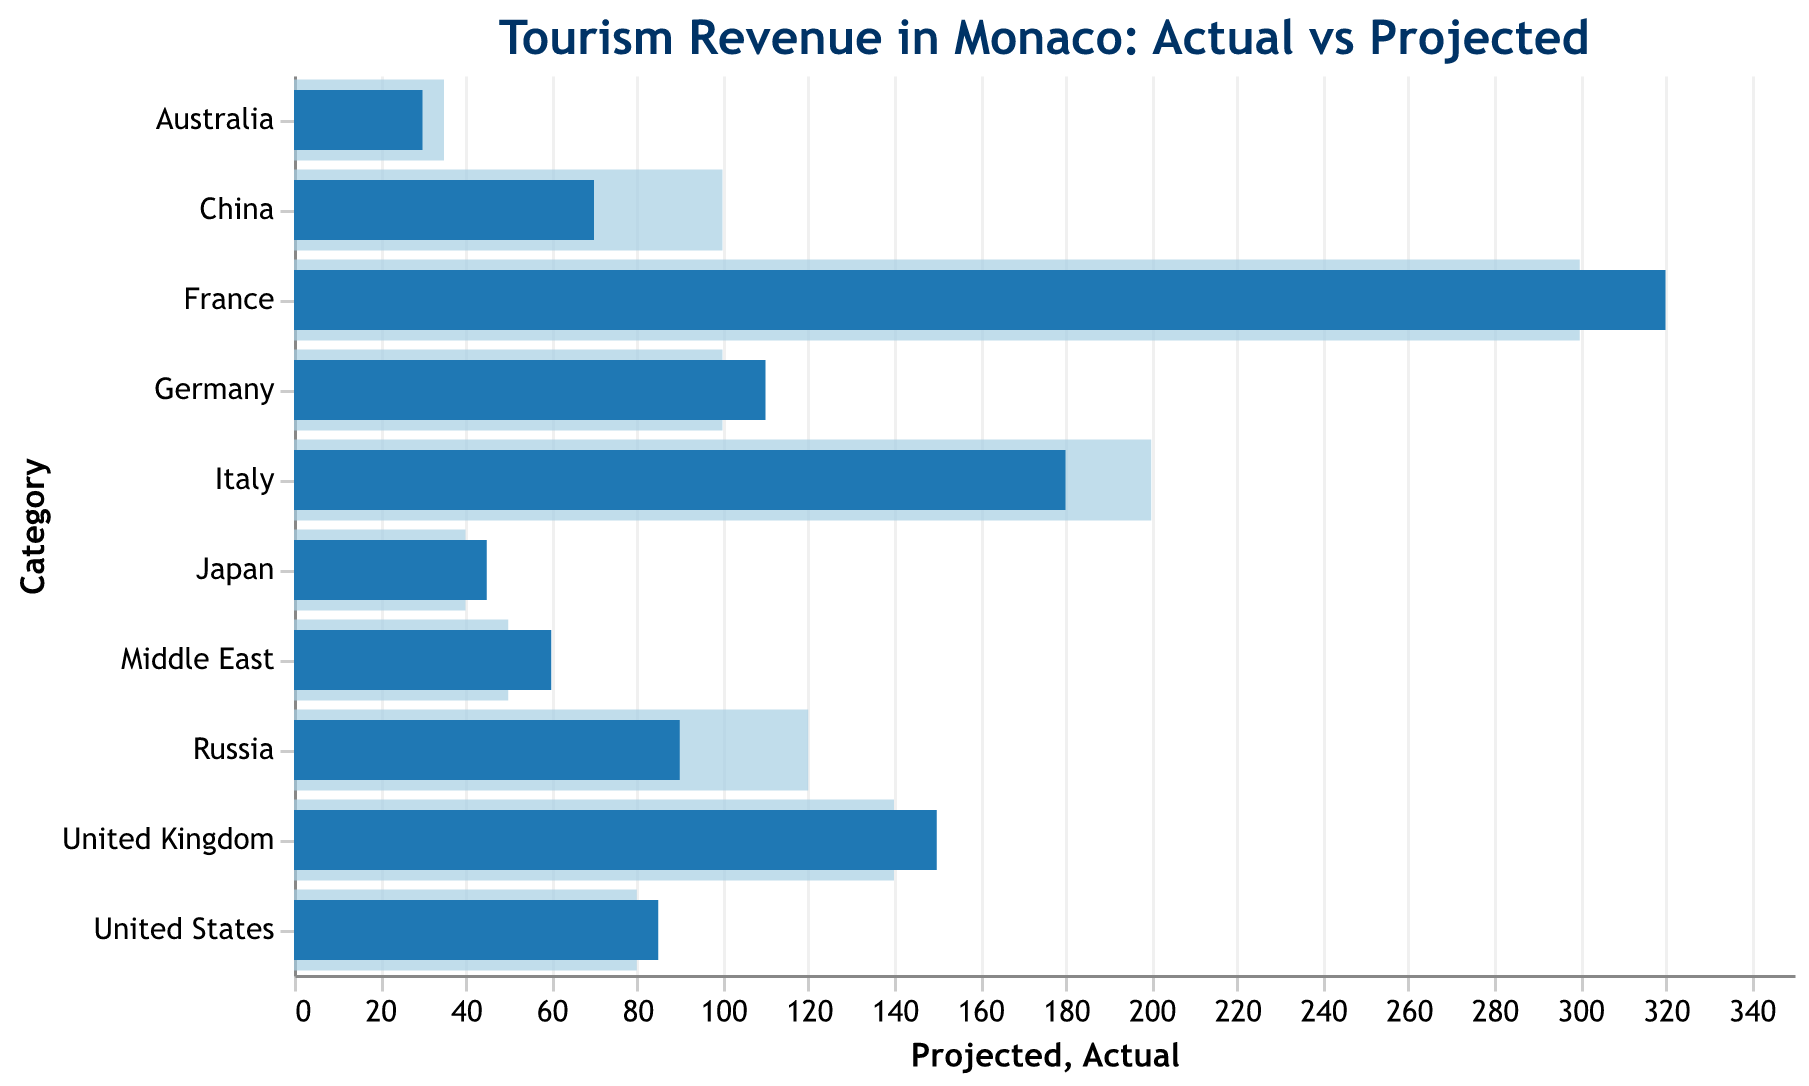What is the title of the chart? The title of the chart is clearly displayed at the top.
Answer: Tourism Revenue in Monaco: Actual vs Projected Which category has the highest actual revenue? The longest blue bar represents the category with the highest actual revenue.
Answer: France How many European countries are represented in the data? By counting the categories listed as European in the 'Origin' column.
Answer: 5 What is the difference in actual revenue between France and Italy? Subtract Italy's actual revenue from France's actual revenue.
Answer: 320 - 180 = 140 Which category has a higher actual revenue, Russia or the United States? Compare the blue bars for both categories.
Answer: Russia Which category has a higher projected revenue than actual revenue? Look for categories where the light blue bar (projected) is longer than the dark blue bar (actual).
Answer: Italy, Russia, China, Australia What is the total actual revenue for Asian visitors? Sum up the actual revenue of the Asian countries (China and Japan).
Answer: 70 + 45 = 115 Which region has the most categories listed under it? Count the categories for each region in the 'Origin' column.
Answer: European What is the most notable discrepancy between actual and projected revenues? Identify the category with the greatest difference between actual and projected revenues.
Answer: China How does the actual revenue from Middle Eastern visitors compare to the projected revenue? Compare the length of the dark blue and light blue bars for the Middle East category.
Answer: Actual is higher than projected 